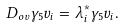Convert formula to latex. <formula><loc_0><loc_0><loc_500><loc_500>D _ { o v } \gamma _ { 5 } v _ { i } = \lambda _ { i } ^ { * } \gamma _ { 5 } v _ { i } .</formula> 